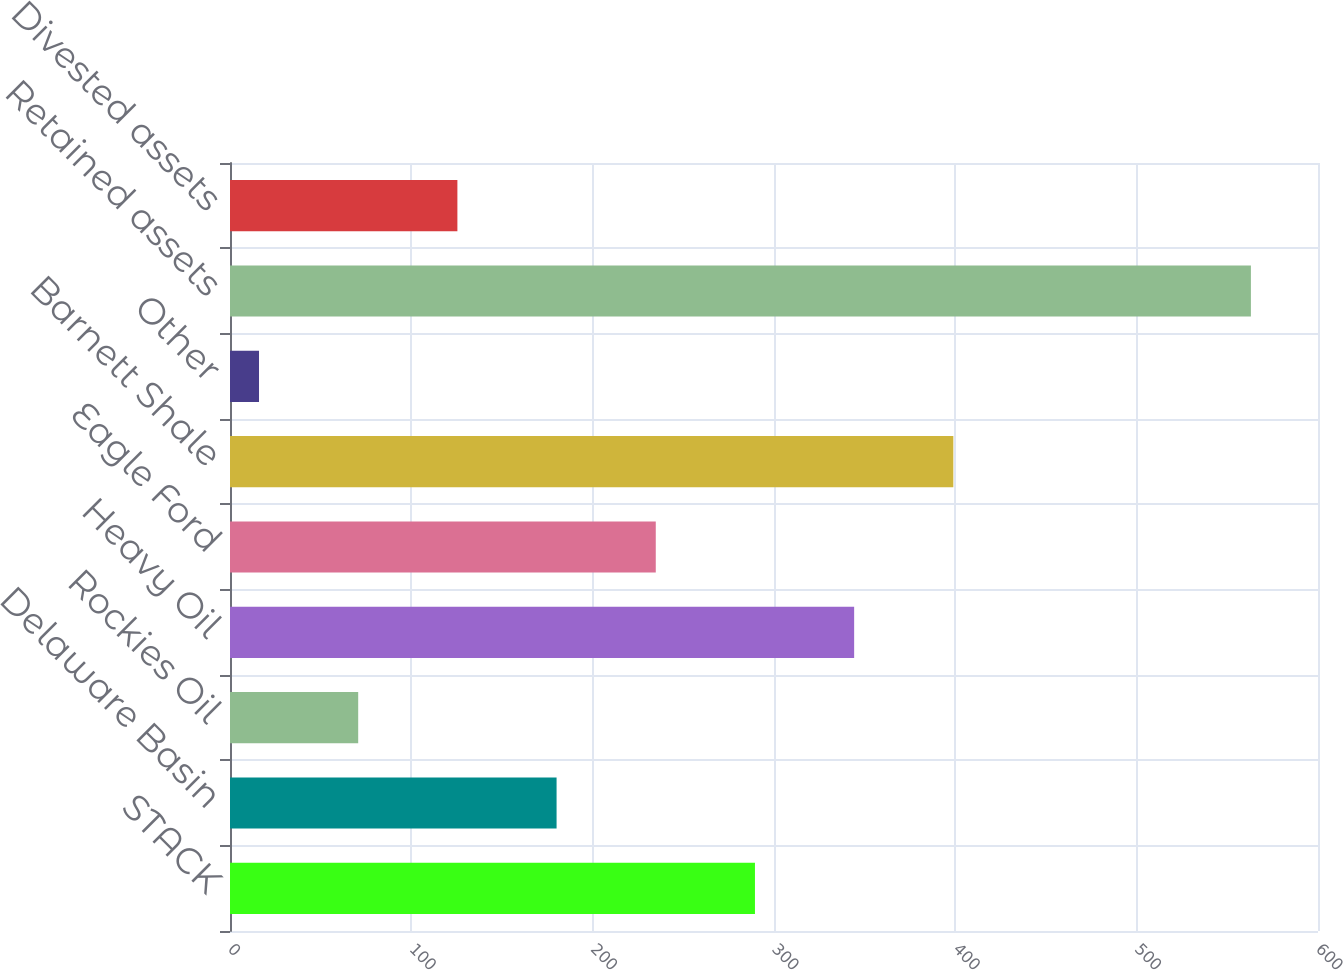Convert chart to OTSL. <chart><loc_0><loc_0><loc_500><loc_500><bar_chart><fcel>STACK<fcel>Delaware Basin<fcel>Rockies Oil<fcel>Heavy Oil<fcel>Eagle Ford<fcel>Barnett Shale<fcel>Other<fcel>Retained assets<fcel>Divested assets<nl><fcel>289.5<fcel>180.1<fcel>70.7<fcel>344.2<fcel>234.8<fcel>398.9<fcel>16<fcel>563<fcel>125.4<nl></chart> 